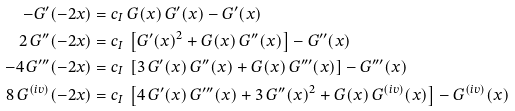<formula> <loc_0><loc_0><loc_500><loc_500>- G ^ { \prime } ( - 2 x ) & = c _ { I } \, G ( x ) \, G ^ { \prime } ( x ) - G ^ { \prime } ( x ) \\ 2 \, G ^ { \prime \prime } ( - 2 x ) & = c _ { I } \, \left [ G ^ { \prime } ( x ) ^ { 2 } + G ( x ) \, G ^ { \prime \prime } ( x ) \right ] - G ^ { \prime \prime } ( x ) \\ - 4 \, G ^ { \prime \prime \prime } ( - 2 x ) & = c _ { I } \, \left [ 3 \, G ^ { \prime } ( x ) \, G ^ { \prime \prime } ( x ) + G ( x ) \, G ^ { \prime \prime \prime } ( x ) \right ] - G ^ { \prime \prime \prime } ( x ) \\ 8 \, G ^ { ( i v ) } ( - 2 x ) & = c _ { I } \, \left [ 4 \, G ^ { \prime } ( x ) \, G ^ { \prime \prime \prime } ( x ) + 3 \, G ^ { \prime \prime } ( x ) ^ { 2 } + G ( x ) \, G ^ { ( i v ) } ( x ) \right ] - G ^ { ( i v ) } ( x )</formula> 